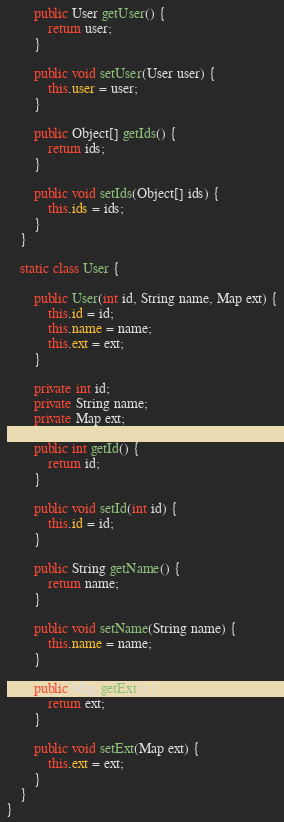<code> <loc_0><loc_0><loc_500><loc_500><_Java_>        public User getUser() {
            return user;
        }

        public void setUser(User user) {
            this.user = user;
        }

        public Object[] getIds() {
            return ids;
        }

        public void setIds(Object[] ids) {
            this.ids = ids;
        }
    }

    static class User {

        public User(int id, String name, Map ext) {
            this.id = id;
            this.name = name;
            this.ext = ext;
        }

        private int id;
        private String name;
        private Map ext;

        public int getId() {
            return id;
        }

        public void setId(int id) {
            this.id = id;
        }

        public String getName() {
            return name;
        }

        public void setName(String name) {
            this.name = name;
        }

        public Map getExt() {
            return ext;
        }

        public void setExt(Map ext) {
            this.ext = ext;
        }
    }
}
</code> 